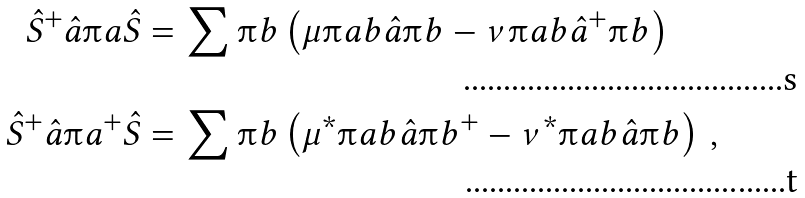Convert formula to latex. <formula><loc_0><loc_0><loc_500><loc_500>\hat { S } ^ { + } \hat { a } \i a \hat { S } & = \sum \i b \left ( \mu \i a b \hat { a } \i b - \nu \i a b \hat { a } ^ { + } \i b \right ) \\ \hat { S } ^ { + } \hat { a } \i a ^ { + } \hat { S } & = \sum \i b \left ( \mu ^ { * } \i a b \hat { a } \i b ^ { + } - \nu ^ { * } \i a b \hat { a } \i b \right ) \, ,</formula> 